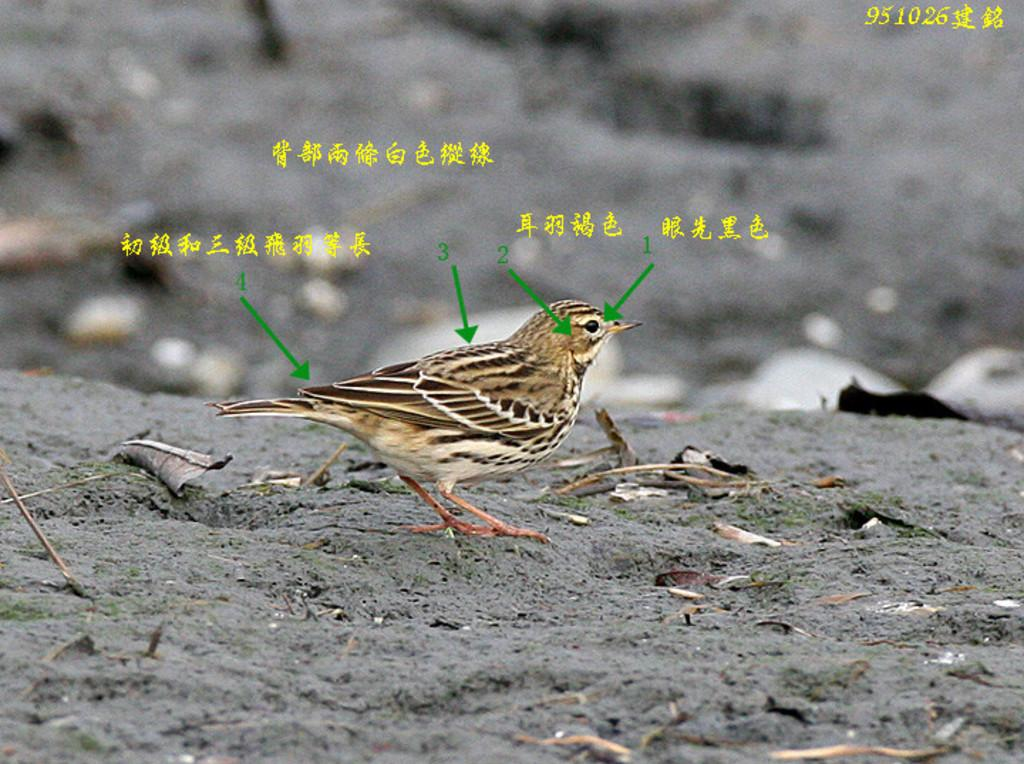What is the main subject in the front of the image? There is a bird in the front of the image. What can be seen at the bottom of the image? There is a leaf at the bottom of the image. How would you describe the background of the image? The background of the image is blurry. What is present in the middle of the image? There is some text in the middle of the image. What sign is the bird holding in the image? There is no sign present in the image, and the bird is not holding anything. 